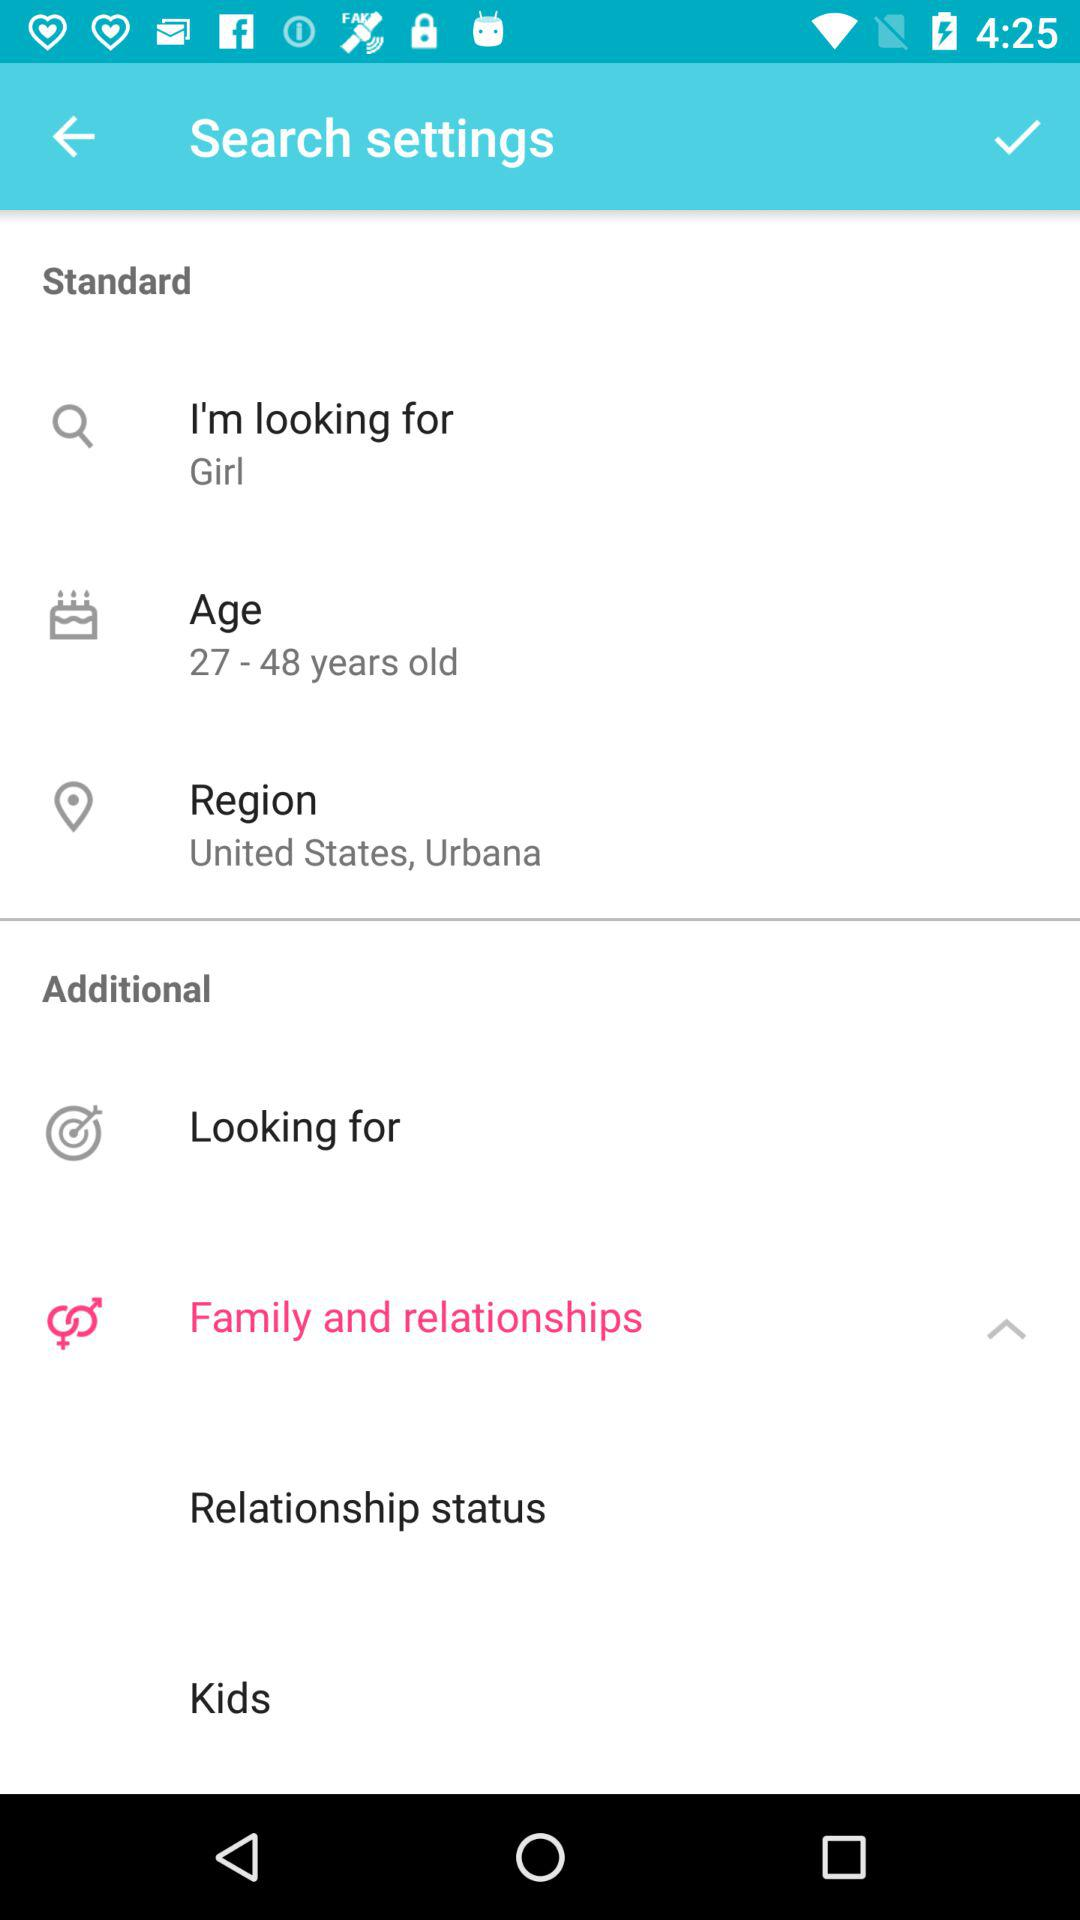What is the gender?
Answer the question using a single word or phrase. It's a girl. 